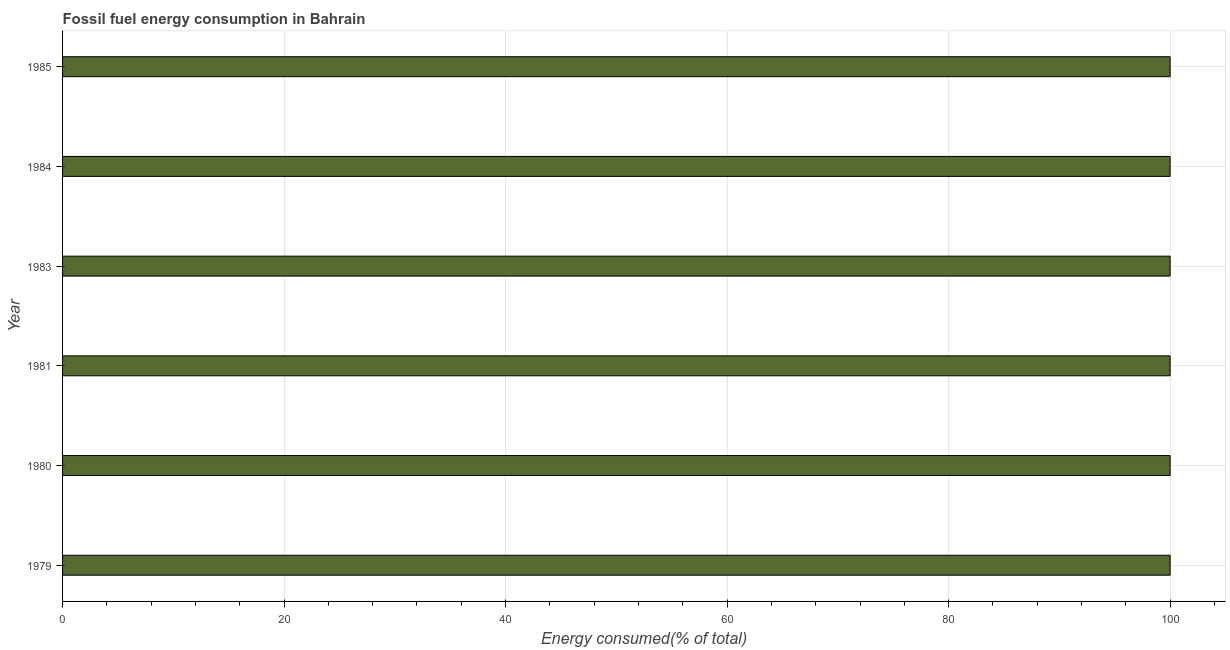Does the graph contain any zero values?
Provide a short and direct response. No. Does the graph contain grids?
Your answer should be very brief. Yes. What is the title of the graph?
Give a very brief answer. Fossil fuel energy consumption in Bahrain. What is the label or title of the X-axis?
Give a very brief answer. Energy consumed(% of total). What is the fossil fuel energy consumption in 1985?
Give a very brief answer. 100. Across all years, what is the maximum fossil fuel energy consumption?
Keep it short and to the point. 100. Across all years, what is the minimum fossil fuel energy consumption?
Your answer should be compact. 100. In which year was the fossil fuel energy consumption minimum?
Your answer should be very brief. 1979. What is the sum of the fossil fuel energy consumption?
Offer a very short reply. 600. What is the difference between the fossil fuel energy consumption in 1983 and 1985?
Offer a terse response. 0. What is the median fossil fuel energy consumption?
Provide a succinct answer. 100. In how many years, is the fossil fuel energy consumption greater than 60 %?
Make the answer very short. 6. What is the ratio of the fossil fuel energy consumption in 1983 to that in 1984?
Your response must be concise. 1. Is the difference between the fossil fuel energy consumption in 1981 and 1983 greater than the difference between any two years?
Provide a short and direct response. No. What is the difference between the highest and the second highest fossil fuel energy consumption?
Keep it short and to the point. 0. Is the sum of the fossil fuel energy consumption in 1981 and 1985 greater than the maximum fossil fuel energy consumption across all years?
Offer a terse response. Yes. Are all the bars in the graph horizontal?
Your answer should be very brief. Yes. How many years are there in the graph?
Provide a succinct answer. 6. What is the Energy consumed(% of total) in 1979?
Keep it short and to the point. 100. What is the Energy consumed(% of total) in 1981?
Make the answer very short. 100. What is the Energy consumed(% of total) in 1985?
Offer a very short reply. 100. What is the difference between the Energy consumed(% of total) in 1979 and 1980?
Your response must be concise. -3e-5. What is the difference between the Energy consumed(% of total) in 1979 and 1981?
Provide a short and direct response. -0. What is the difference between the Energy consumed(% of total) in 1979 and 1983?
Your answer should be very brief. -3e-5. What is the difference between the Energy consumed(% of total) in 1979 and 1984?
Provide a succinct answer. -3e-5. What is the difference between the Energy consumed(% of total) in 1979 and 1985?
Ensure brevity in your answer.  -1e-5. What is the difference between the Energy consumed(% of total) in 1980 and 1981?
Make the answer very short. 3e-5. What is the difference between the Energy consumed(% of total) in 1980 and 1984?
Make the answer very short. 0. What is the difference between the Energy consumed(% of total) in 1980 and 1985?
Provide a succinct answer. 2e-5. What is the difference between the Energy consumed(% of total) in 1981 and 1983?
Your response must be concise. -3e-5. What is the difference between the Energy consumed(% of total) in 1981 and 1984?
Ensure brevity in your answer.  -3e-5. What is the difference between the Energy consumed(% of total) in 1981 and 1985?
Your response must be concise. -1e-5. What is the difference between the Energy consumed(% of total) in 1983 and 1985?
Make the answer very short. 2e-5. What is the difference between the Energy consumed(% of total) in 1984 and 1985?
Your answer should be very brief. 2e-5. What is the ratio of the Energy consumed(% of total) in 1979 to that in 1981?
Your answer should be very brief. 1. What is the ratio of the Energy consumed(% of total) in 1979 to that in 1983?
Your response must be concise. 1. What is the ratio of the Energy consumed(% of total) in 1979 to that in 1985?
Offer a terse response. 1. What is the ratio of the Energy consumed(% of total) in 1980 to that in 1984?
Your answer should be compact. 1. What is the ratio of the Energy consumed(% of total) in 1981 to that in 1983?
Your answer should be very brief. 1. What is the ratio of the Energy consumed(% of total) in 1981 to that in 1985?
Your answer should be very brief. 1. What is the ratio of the Energy consumed(% of total) in 1983 to that in 1985?
Make the answer very short. 1. What is the ratio of the Energy consumed(% of total) in 1984 to that in 1985?
Ensure brevity in your answer.  1. 